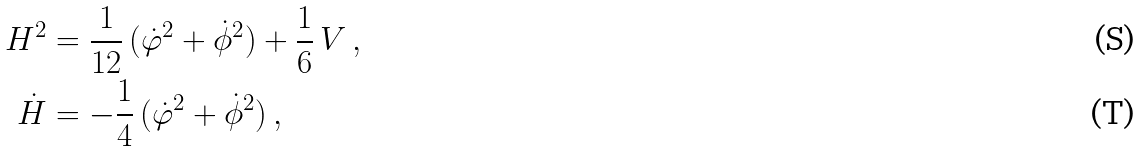Convert formula to latex. <formula><loc_0><loc_0><loc_500><loc_500>H ^ { 2 } & = \frac { 1 } { 1 2 } \, ( \dot { \varphi } ^ { 2 } + \dot { \phi } ^ { 2 } ) + \frac { 1 } { 6 } \, { V } \, , \\ \dot { H } & = - \frac { 1 } { 4 } \, ( \dot { \varphi } ^ { 2 } + \dot { \phi } ^ { 2 } ) \, ,</formula> 